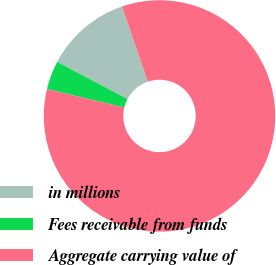Convert chart to OTSL. <chart><loc_0><loc_0><loc_500><loc_500><pie_chart><fcel>in millions<fcel>Fees receivable from funds<fcel>Aggregate carrying value of<nl><fcel>12.01%<fcel>4.01%<fcel>83.97%<nl></chart> 